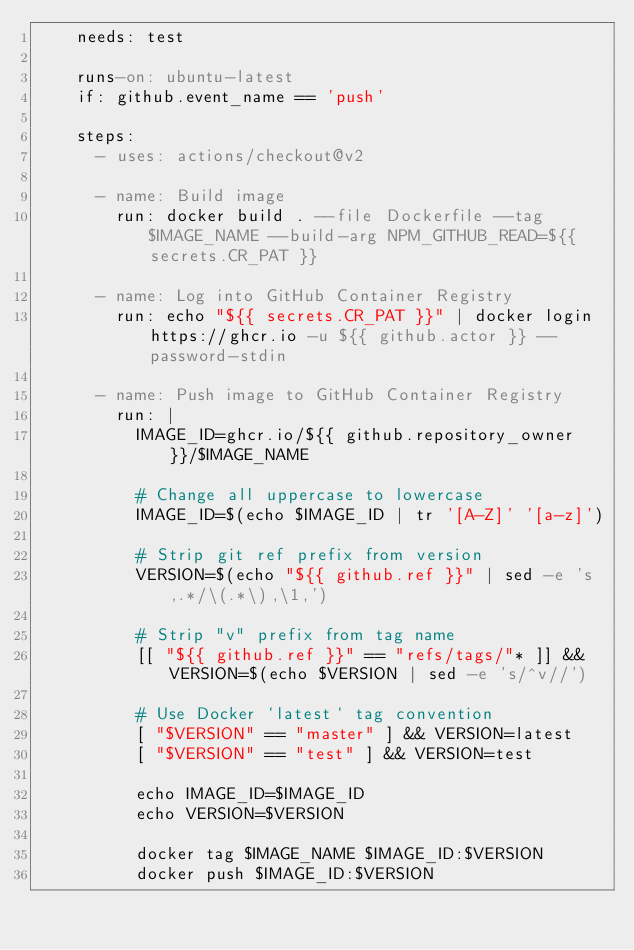Convert code to text. <code><loc_0><loc_0><loc_500><loc_500><_YAML_>    needs: test

    runs-on: ubuntu-latest
    if: github.event_name == 'push'

    steps:
      - uses: actions/checkout@v2

      - name: Build image
        run: docker build . --file Dockerfile --tag $IMAGE_NAME --build-arg NPM_GITHUB_READ=${{ secrets.CR_PAT }}

      - name: Log into GitHub Container Registry
        run: echo "${{ secrets.CR_PAT }}" | docker login https://ghcr.io -u ${{ github.actor }} --password-stdin

      - name: Push image to GitHub Container Registry
        run: |
          IMAGE_ID=ghcr.io/${{ github.repository_owner }}/$IMAGE_NAME

          # Change all uppercase to lowercase
          IMAGE_ID=$(echo $IMAGE_ID | tr '[A-Z]' '[a-z]')

          # Strip git ref prefix from version
          VERSION=$(echo "${{ github.ref }}" | sed -e 's,.*/\(.*\),\1,')

          # Strip "v" prefix from tag name
          [[ "${{ github.ref }}" == "refs/tags/"* ]] && VERSION=$(echo $VERSION | sed -e 's/^v//')

          # Use Docker `latest` tag convention
          [ "$VERSION" == "master" ] && VERSION=latest
          [ "$VERSION" == "test" ] && VERSION=test

          echo IMAGE_ID=$IMAGE_ID
          echo VERSION=$VERSION

          docker tag $IMAGE_NAME $IMAGE_ID:$VERSION
          docker push $IMAGE_ID:$VERSION
</code> 